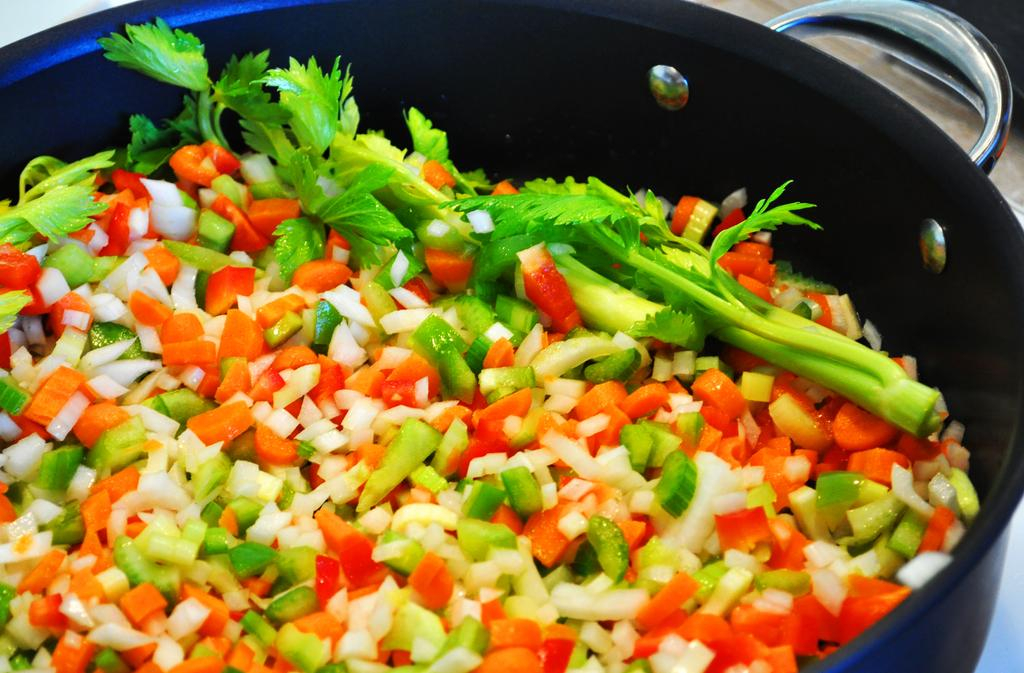What type of food items can be seen in the image? There are chopped vegetables in the image. Where are the chopped vegetables located? The chopped vegetables are in a bowl. What additional ingredient is present in the image? There are coriander leaves present in the image. Can you see a ghost in the image? No, there is no ghost present in the image. What type of tent is visible in the image? There is no tent present in the image. 